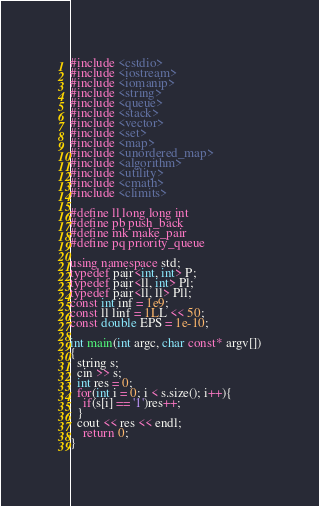Convert code to text. <code><loc_0><loc_0><loc_500><loc_500><_C++_>#include <cstdio>
#include <iostream>
#include <iomanip>
#include <string>
#include <queue>
#include <stack>
#include <vector>
#include <set>
#include <map>
#include <unordered_map>
#include <algorithm>
#include <utility>
#include <cmath>
#include <climits>

#define ll long long int
#define pb push_back
#define mk make_pair
#define pq priority_queue

using namespace std;
typedef pair<int, int> P;
typedef pair<ll, int> Pl;
typedef pair<ll, ll> Pll;
const int inf = 1e9;
const ll linf = 1LL << 50;
const double EPS = 1e-10;

int main(int argc, char const* argv[])
{
  string s;
  cin >> s;
  int res = 0;
  for(int i = 0; i < s.size(); i++){
    if(s[i] == '1')res++;
  }
  cout << res << endl;
	return 0;
}
</code> 